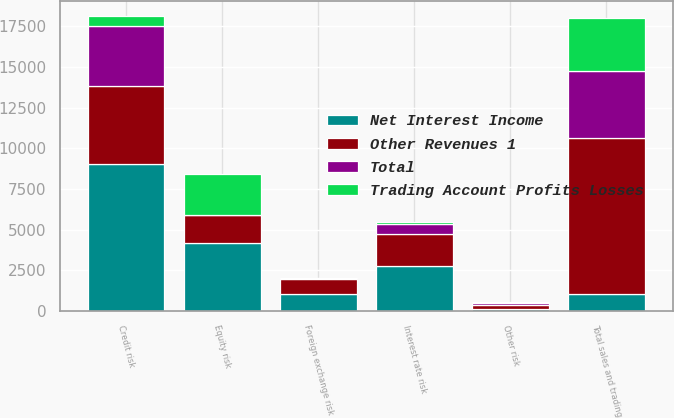Convert chart to OTSL. <chart><loc_0><loc_0><loc_500><loc_500><stacked_bar_chart><ecel><fcel>Interest rate risk<fcel>Equity risk<fcel>Credit risk<fcel>Other risk<fcel>Total sales and trading<fcel>Foreign exchange risk<nl><fcel>Other Revenues 1<fcel>2004<fcel>1670<fcel>4791<fcel>228<fcel>9596<fcel>972<nl><fcel>Trading Account Profits Losses<fcel>113<fcel>2506<fcel>617<fcel>39<fcel>3278<fcel>6<nl><fcel>Total<fcel>624<fcel>21<fcel>3652<fcel>142<fcel>4155<fcel>26<nl><fcel>Net Interest Income<fcel>2741<fcel>4197<fcel>9060<fcel>125<fcel>1004<fcel>1004<nl></chart> 